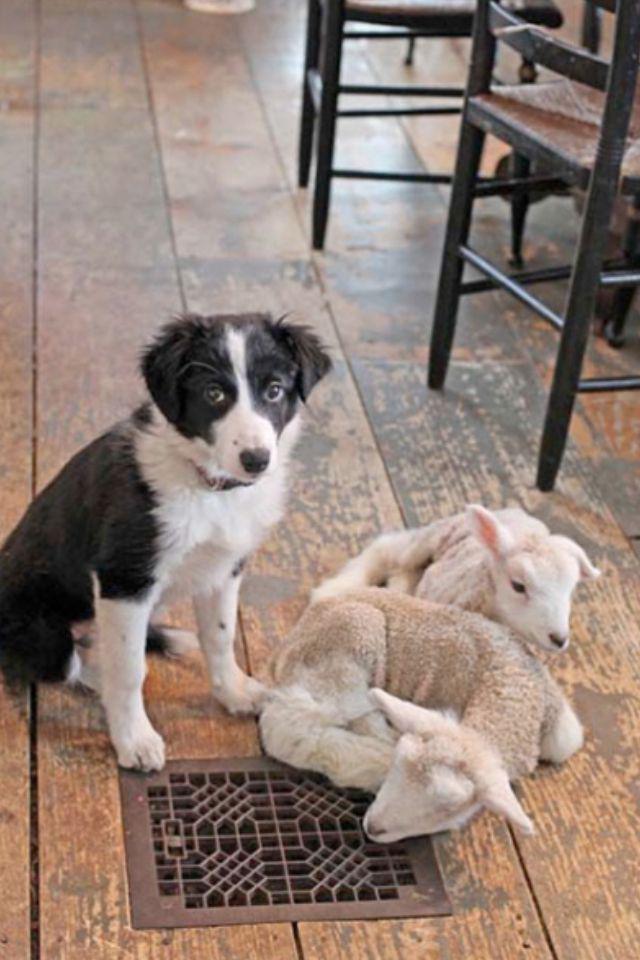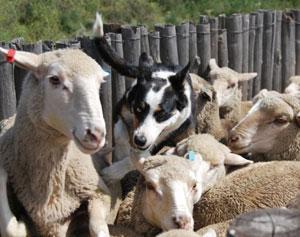The first image is the image on the left, the second image is the image on the right. For the images displayed, is the sentence "Right image contains one dog sitting up." factually correct? Answer yes or no. No. The first image is the image on the left, the second image is the image on the right. Assess this claim about the two images: "In one image, a black and white dog is outdoors with sheep.". Correct or not? Answer yes or no. Yes. 